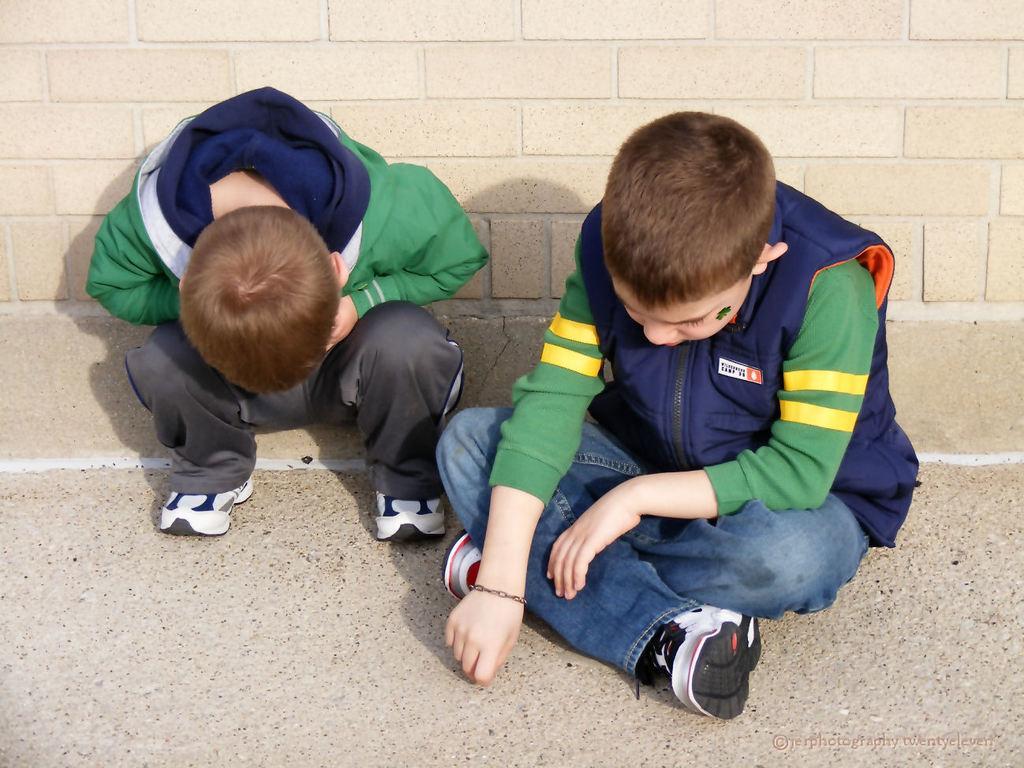Describe this image in one or two sentences. In this picture there are two boys sitting on the floor. At the back there is a wall. At the bottom right there is a text. 